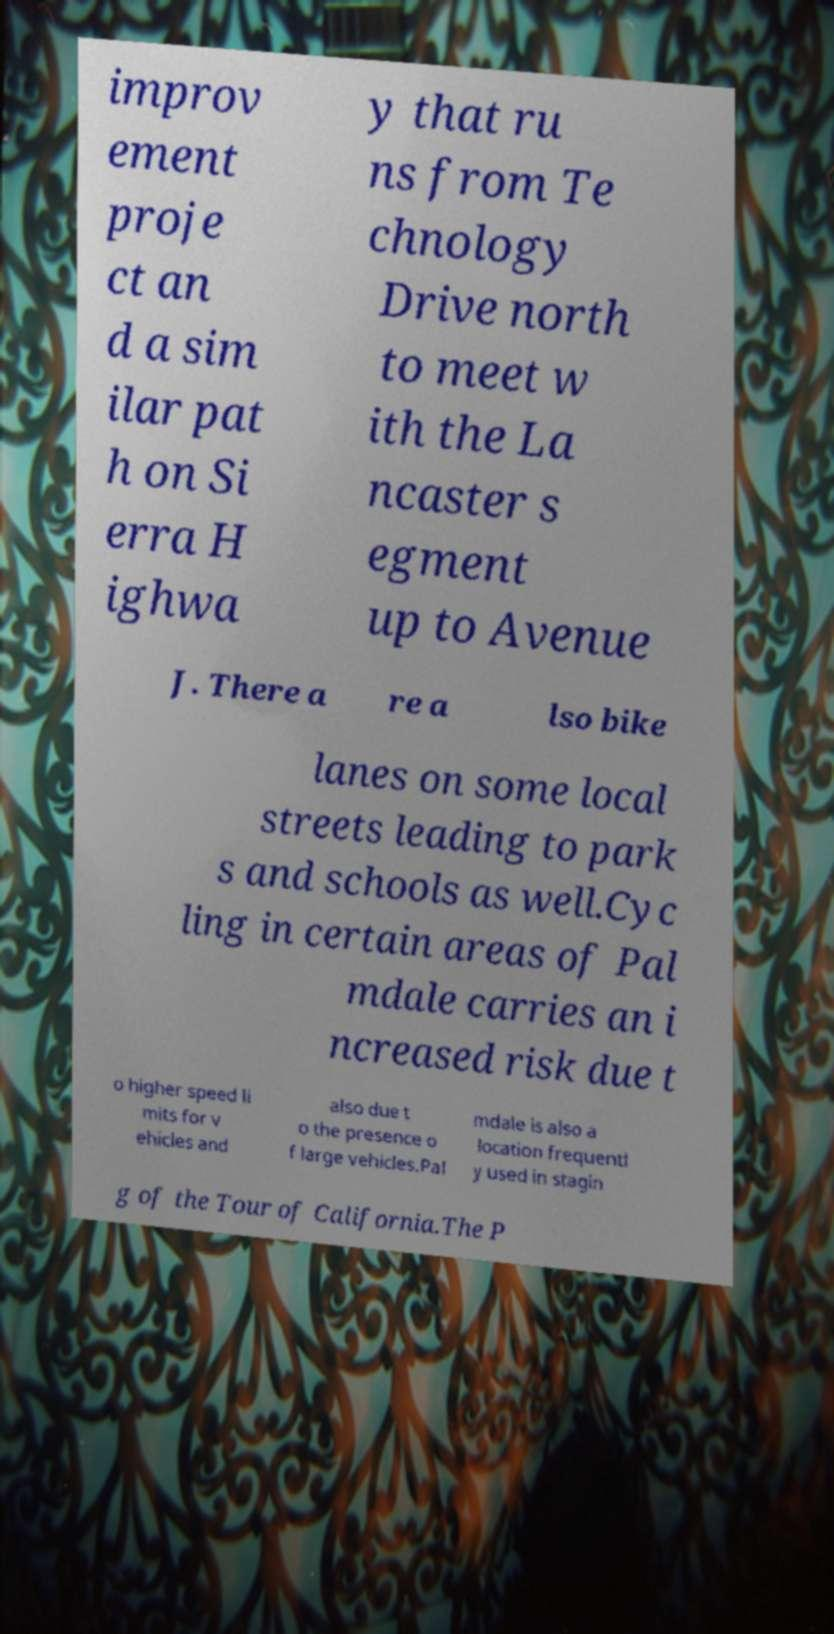I need the written content from this picture converted into text. Can you do that? improv ement proje ct an d a sim ilar pat h on Si erra H ighwa y that ru ns from Te chnology Drive north to meet w ith the La ncaster s egment up to Avenue J. There a re a lso bike lanes on some local streets leading to park s and schools as well.Cyc ling in certain areas of Pal mdale carries an i ncreased risk due t o higher speed li mits for v ehicles and also due t o the presence o f large vehicles.Pal mdale is also a location frequentl y used in stagin g of the Tour of California.The P 